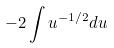Convert formula to latex. <formula><loc_0><loc_0><loc_500><loc_500>- 2 \int u ^ { - 1 / 2 } d u</formula> 